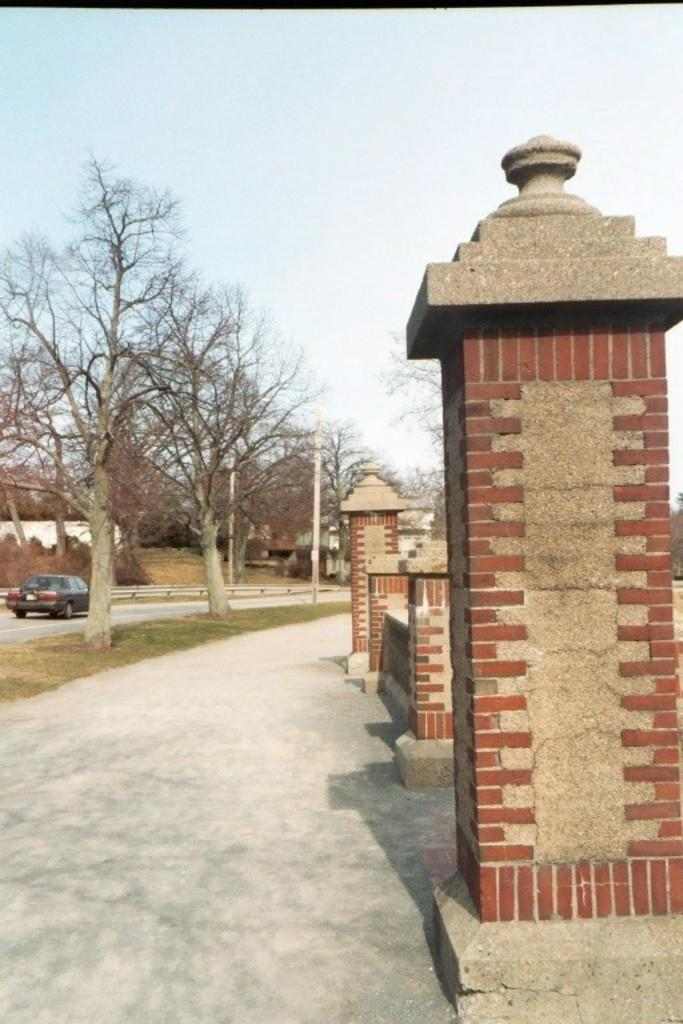What type of vegetation can be seen in the image? There are trees in the image. What type of structures are present in the image? There are sheds and pillars in the image. What is the purpose of the pole in the image? The purpose of the pole is not specified, but it could be for supporting a sign or a light. What is the main mode of transportation visible in the image? There is a car on the road in the image. What is visible at the top of the image? The sky is visible at the top of the image. What type of cream is being used to decorate the bun in the image? There is no bun or cream present in the image; it features trees, sheds, pillars, a pole, a car, and the sky. 